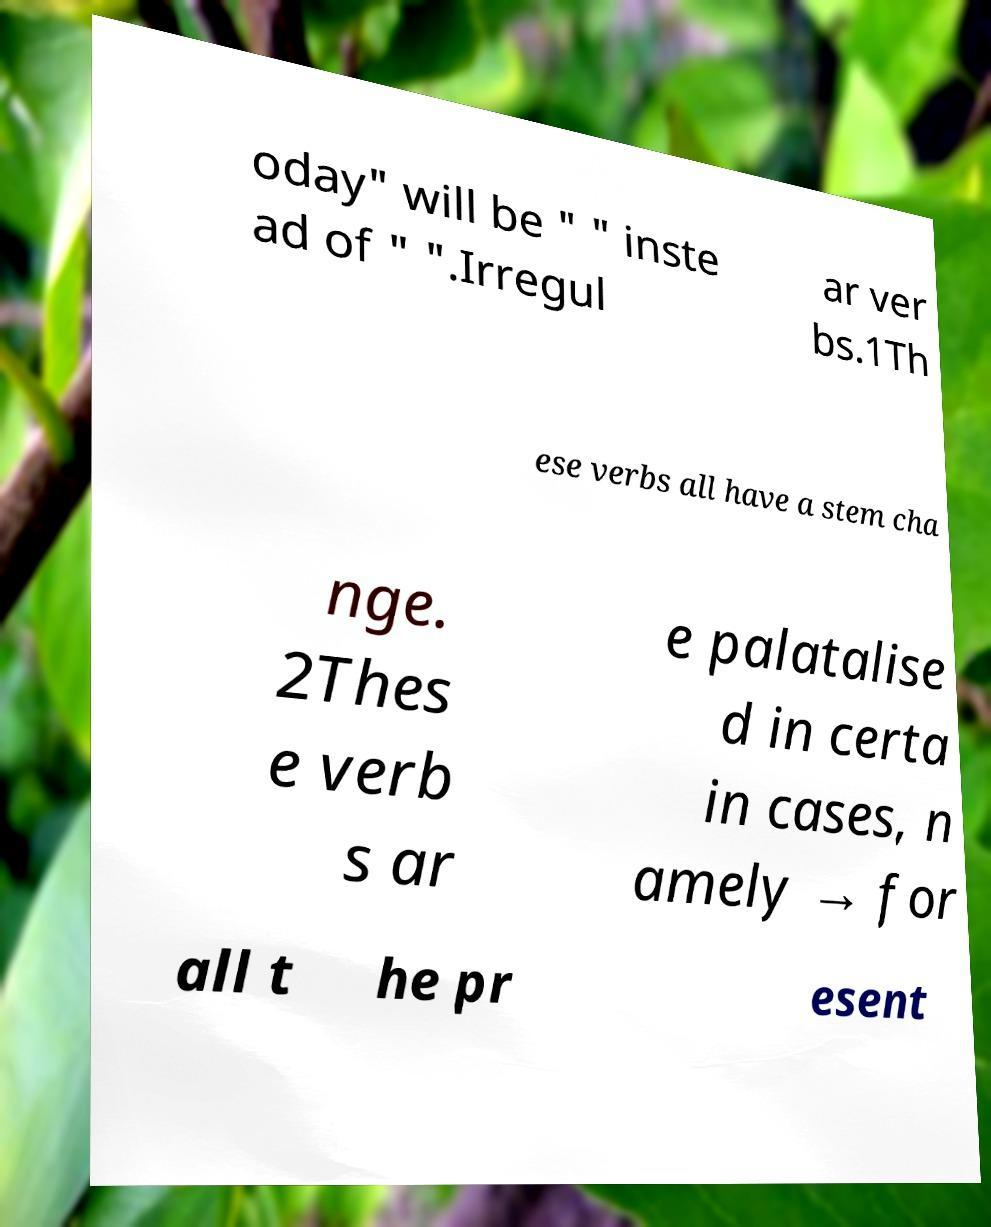I need the written content from this picture converted into text. Can you do that? oday" will be " " inste ad of " ".Irregul ar ver bs.1Th ese verbs all have a stem cha nge. 2Thes e verb s ar e palatalise d in certa in cases, n amely → for all t he pr esent 